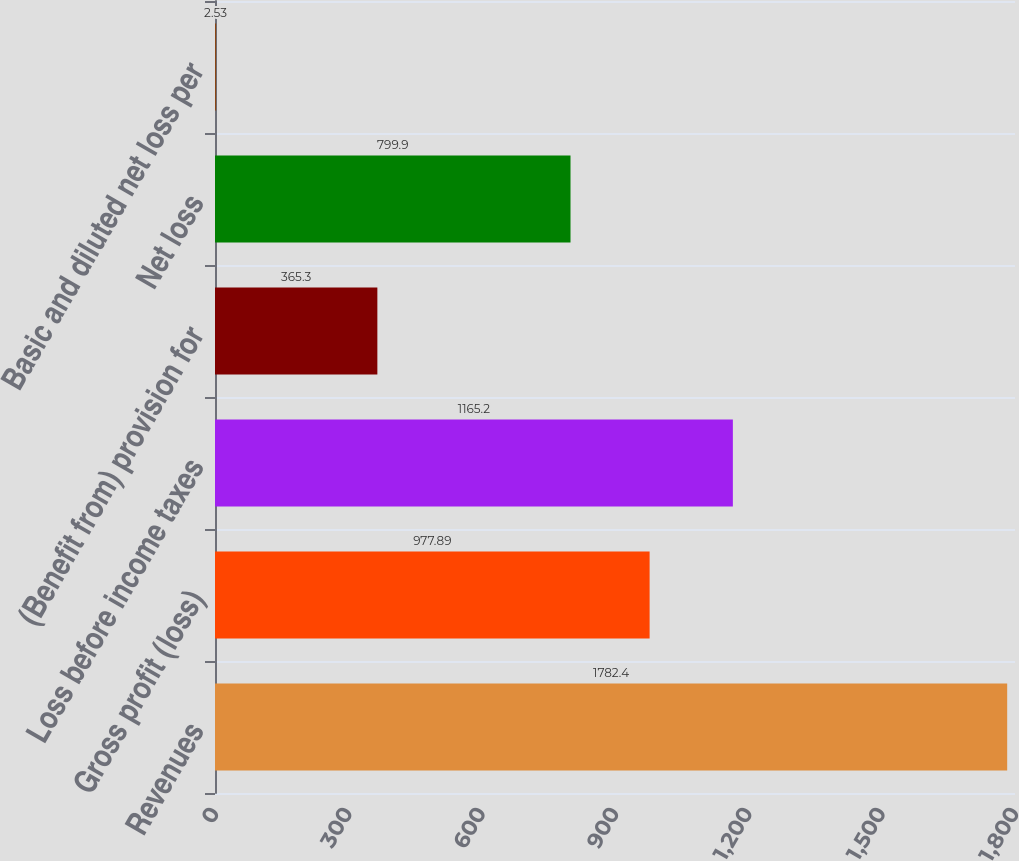<chart> <loc_0><loc_0><loc_500><loc_500><bar_chart><fcel>Revenues<fcel>Gross profit (loss)<fcel>Loss before income taxes<fcel>(Benefit from) provision for<fcel>Net loss<fcel>Basic and diluted net loss per<nl><fcel>1782.4<fcel>977.89<fcel>1165.2<fcel>365.3<fcel>799.9<fcel>2.53<nl></chart> 